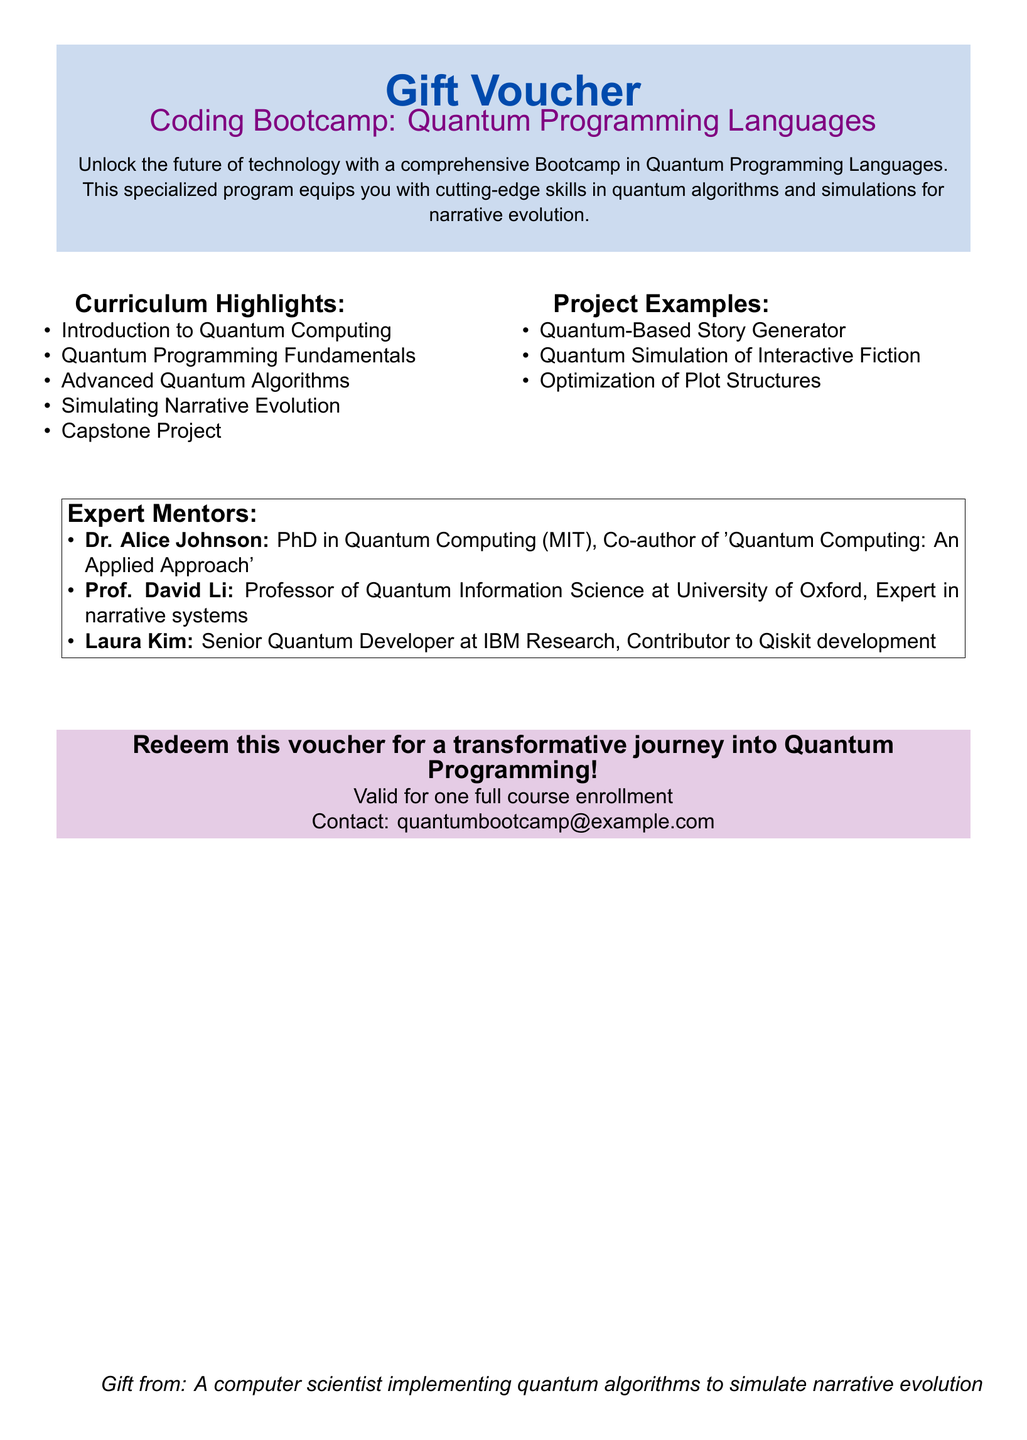What is the title of the Bootcamp? The title of the Bootcamp is stated as "Coding Bootcamp: Quantum Programming Languages."
Answer: Coding Bootcamp: Quantum Programming Languages Who is an expert mentor with a PhD from MIT? The expert mentor with a PhD from MIT is Dr. Alice Johnson.
Answer: Dr. Alice Johnson What is one of the curriculum highlights? The document lists several curriculum highlights, one of which is "Simulating Narrative Evolution."
Answer: Simulating Narrative Evolution How many expert mentors are listed? The document mentions a total of three expert mentors.
Answer: Three What is the contact email for the Bootcamp? The contact email provided in the document for the Bootcamp is "quantumbootcamp@example.com."
Answer: quantumbootcamp@example.com 